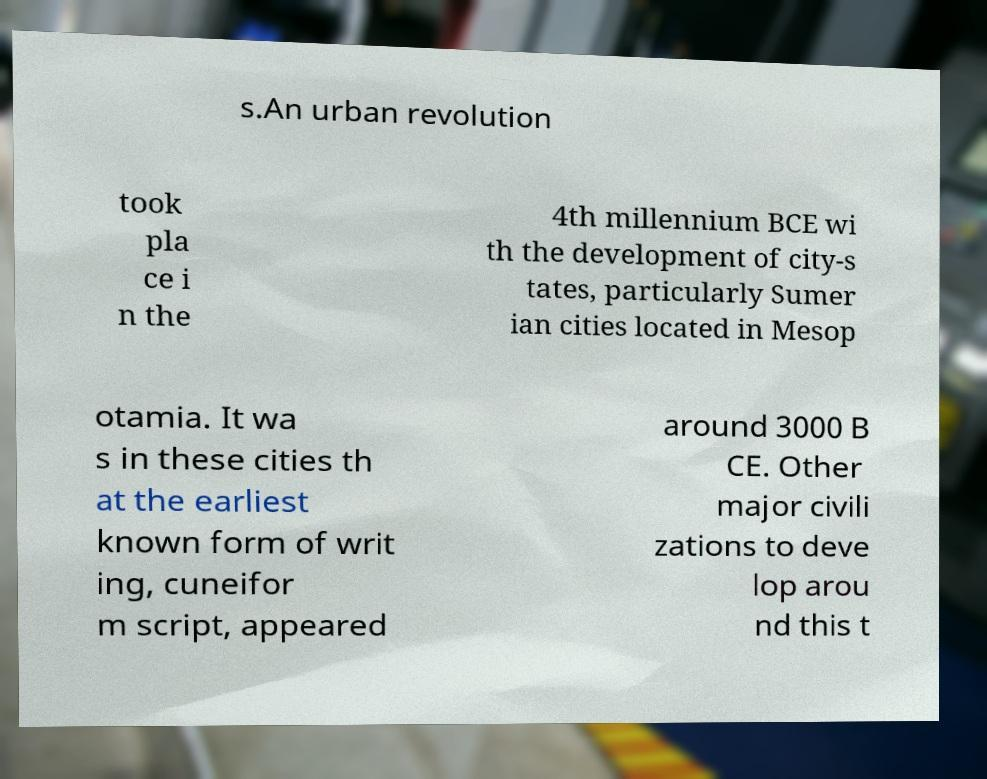Please identify and transcribe the text found in this image. s.An urban revolution took pla ce i n the 4th millennium BCE wi th the development of city-s tates, particularly Sumer ian cities located in Mesop otamia. It wa s in these cities th at the earliest known form of writ ing, cuneifor m script, appeared around 3000 B CE. Other major civili zations to deve lop arou nd this t 